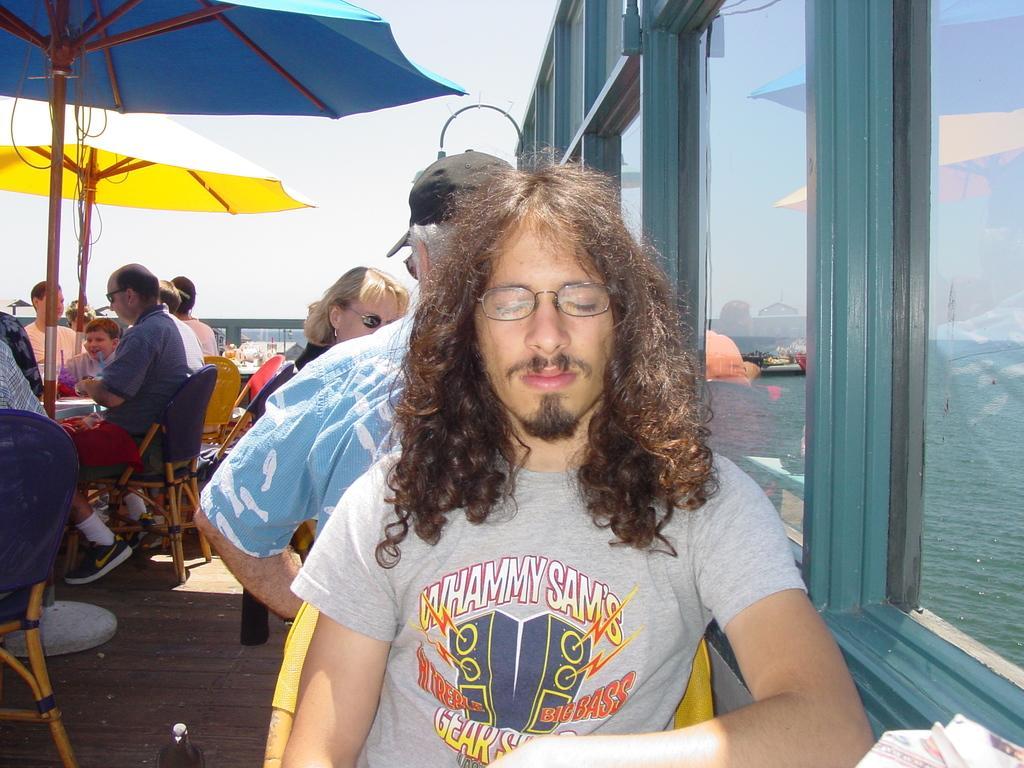Could you give a brief overview of what you see in this image? There are people sitting on the chairs as we can see on the left side of this image. We can see a wooden door and glass windows are present on the right side of this image. There is a sky in the background. We can see umbrellas on the left side of this image. 